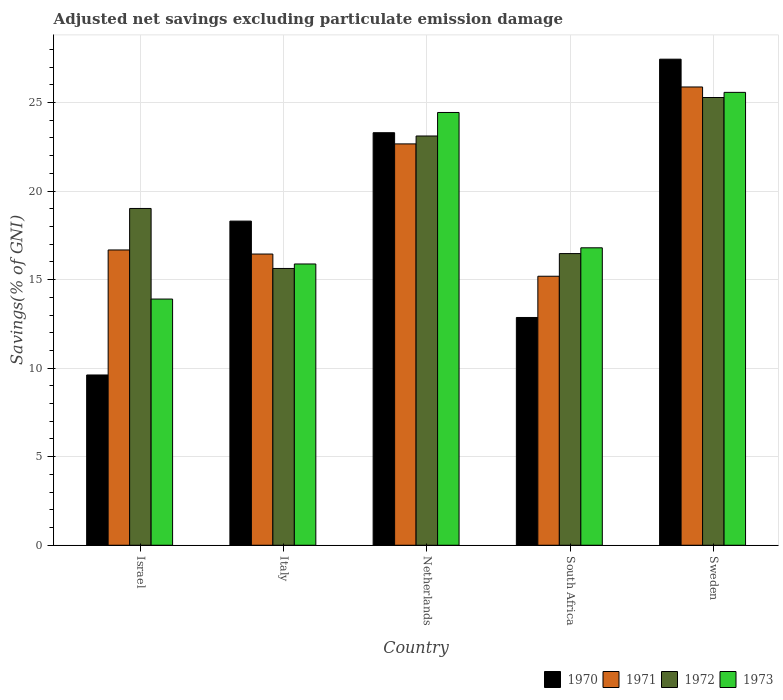How many different coloured bars are there?
Give a very brief answer. 4. How many bars are there on the 4th tick from the left?
Ensure brevity in your answer.  4. What is the adjusted net savings in 1970 in Italy?
Your response must be concise. 18.3. Across all countries, what is the maximum adjusted net savings in 1973?
Keep it short and to the point. 25.57. Across all countries, what is the minimum adjusted net savings in 1971?
Offer a very short reply. 15.19. In which country was the adjusted net savings in 1972 maximum?
Give a very brief answer. Sweden. In which country was the adjusted net savings in 1971 minimum?
Your answer should be compact. South Africa. What is the total adjusted net savings in 1973 in the graph?
Ensure brevity in your answer.  96.59. What is the difference between the adjusted net savings in 1972 in Italy and that in Netherlands?
Ensure brevity in your answer.  -7.48. What is the difference between the adjusted net savings in 1970 in Netherlands and the adjusted net savings in 1971 in Israel?
Give a very brief answer. 6.62. What is the average adjusted net savings in 1970 per country?
Ensure brevity in your answer.  18.3. What is the difference between the adjusted net savings of/in 1973 and adjusted net savings of/in 1970 in Netherlands?
Your response must be concise. 1.14. In how many countries, is the adjusted net savings in 1973 greater than 15 %?
Offer a very short reply. 4. What is the ratio of the adjusted net savings in 1973 in Israel to that in South Africa?
Provide a short and direct response. 0.83. Is the adjusted net savings in 1970 in Israel less than that in Italy?
Your response must be concise. Yes. What is the difference between the highest and the second highest adjusted net savings in 1972?
Make the answer very short. 6.27. What is the difference between the highest and the lowest adjusted net savings in 1973?
Keep it short and to the point. 11.67. In how many countries, is the adjusted net savings in 1972 greater than the average adjusted net savings in 1972 taken over all countries?
Provide a short and direct response. 2. What does the 1st bar from the left in Netherlands represents?
Your answer should be compact. 1970. What does the 1st bar from the right in Italy represents?
Make the answer very short. 1973. Is it the case that in every country, the sum of the adjusted net savings in 1970 and adjusted net savings in 1973 is greater than the adjusted net savings in 1972?
Your response must be concise. Yes. Are all the bars in the graph horizontal?
Offer a very short reply. No. How many countries are there in the graph?
Offer a terse response. 5. Does the graph contain any zero values?
Your response must be concise. No. What is the title of the graph?
Ensure brevity in your answer.  Adjusted net savings excluding particulate emission damage. Does "2007" appear as one of the legend labels in the graph?
Make the answer very short. No. What is the label or title of the X-axis?
Ensure brevity in your answer.  Country. What is the label or title of the Y-axis?
Give a very brief answer. Savings(% of GNI). What is the Savings(% of GNI) of 1970 in Israel?
Provide a short and direct response. 9.61. What is the Savings(% of GNI) of 1971 in Israel?
Provide a succinct answer. 16.67. What is the Savings(% of GNI) of 1972 in Israel?
Your answer should be compact. 19.02. What is the Savings(% of GNI) in 1973 in Israel?
Your answer should be very brief. 13.9. What is the Savings(% of GNI) of 1970 in Italy?
Offer a terse response. 18.3. What is the Savings(% of GNI) of 1971 in Italy?
Ensure brevity in your answer.  16.44. What is the Savings(% of GNI) in 1972 in Italy?
Provide a succinct answer. 15.63. What is the Savings(% of GNI) of 1973 in Italy?
Offer a very short reply. 15.88. What is the Savings(% of GNI) of 1970 in Netherlands?
Provide a succinct answer. 23.3. What is the Savings(% of GNI) in 1971 in Netherlands?
Your answer should be very brief. 22.66. What is the Savings(% of GNI) of 1972 in Netherlands?
Your response must be concise. 23.11. What is the Savings(% of GNI) in 1973 in Netherlands?
Offer a terse response. 24.44. What is the Savings(% of GNI) in 1970 in South Africa?
Offer a very short reply. 12.86. What is the Savings(% of GNI) in 1971 in South Africa?
Provide a succinct answer. 15.19. What is the Savings(% of GNI) in 1972 in South Africa?
Your answer should be compact. 16.47. What is the Savings(% of GNI) in 1973 in South Africa?
Provide a short and direct response. 16.8. What is the Savings(% of GNI) of 1970 in Sweden?
Your answer should be very brief. 27.45. What is the Savings(% of GNI) in 1971 in Sweden?
Give a very brief answer. 25.88. What is the Savings(% of GNI) of 1972 in Sweden?
Keep it short and to the point. 25.28. What is the Savings(% of GNI) of 1973 in Sweden?
Keep it short and to the point. 25.57. Across all countries, what is the maximum Savings(% of GNI) of 1970?
Make the answer very short. 27.45. Across all countries, what is the maximum Savings(% of GNI) of 1971?
Your response must be concise. 25.88. Across all countries, what is the maximum Savings(% of GNI) of 1972?
Give a very brief answer. 25.28. Across all countries, what is the maximum Savings(% of GNI) of 1973?
Your answer should be very brief. 25.57. Across all countries, what is the minimum Savings(% of GNI) in 1970?
Offer a terse response. 9.61. Across all countries, what is the minimum Savings(% of GNI) in 1971?
Make the answer very short. 15.19. Across all countries, what is the minimum Savings(% of GNI) of 1972?
Offer a very short reply. 15.63. Across all countries, what is the minimum Savings(% of GNI) in 1973?
Ensure brevity in your answer.  13.9. What is the total Savings(% of GNI) in 1970 in the graph?
Offer a very short reply. 91.52. What is the total Savings(% of GNI) of 1971 in the graph?
Offer a very short reply. 96.85. What is the total Savings(% of GNI) of 1972 in the graph?
Offer a very short reply. 99.51. What is the total Savings(% of GNI) of 1973 in the graph?
Your answer should be compact. 96.59. What is the difference between the Savings(% of GNI) in 1970 in Israel and that in Italy?
Ensure brevity in your answer.  -8.69. What is the difference between the Savings(% of GNI) of 1971 in Israel and that in Italy?
Your answer should be compact. 0.23. What is the difference between the Savings(% of GNI) of 1972 in Israel and that in Italy?
Offer a very short reply. 3.39. What is the difference between the Savings(% of GNI) of 1973 in Israel and that in Italy?
Give a very brief answer. -1.98. What is the difference between the Savings(% of GNI) of 1970 in Israel and that in Netherlands?
Offer a very short reply. -13.68. What is the difference between the Savings(% of GNI) in 1971 in Israel and that in Netherlands?
Offer a terse response. -5.99. What is the difference between the Savings(% of GNI) of 1972 in Israel and that in Netherlands?
Your answer should be very brief. -4.09. What is the difference between the Savings(% of GNI) of 1973 in Israel and that in Netherlands?
Your response must be concise. -10.54. What is the difference between the Savings(% of GNI) of 1970 in Israel and that in South Africa?
Offer a very short reply. -3.25. What is the difference between the Savings(% of GNI) in 1971 in Israel and that in South Africa?
Make the answer very short. 1.48. What is the difference between the Savings(% of GNI) in 1972 in Israel and that in South Africa?
Your response must be concise. 2.55. What is the difference between the Savings(% of GNI) in 1973 in Israel and that in South Africa?
Your response must be concise. -2.89. What is the difference between the Savings(% of GNI) of 1970 in Israel and that in Sweden?
Give a very brief answer. -17.83. What is the difference between the Savings(% of GNI) of 1971 in Israel and that in Sweden?
Keep it short and to the point. -9.2. What is the difference between the Savings(% of GNI) of 1972 in Israel and that in Sweden?
Offer a very short reply. -6.27. What is the difference between the Savings(% of GNI) of 1973 in Israel and that in Sweden?
Keep it short and to the point. -11.67. What is the difference between the Savings(% of GNI) in 1970 in Italy and that in Netherlands?
Offer a terse response. -4.99. What is the difference between the Savings(% of GNI) of 1971 in Italy and that in Netherlands?
Make the answer very short. -6.22. What is the difference between the Savings(% of GNI) of 1972 in Italy and that in Netherlands?
Make the answer very short. -7.48. What is the difference between the Savings(% of GNI) of 1973 in Italy and that in Netherlands?
Provide a succinct answer. -8.56. What is the difference between the Savings(% of GNI) in 1970 in Italy and that in South Africa?
Make the answer very short. 5.44. What is the difference between the Savings(% of GNI) of 1971 in Italy and that in South Africa?
Your answer should be compact. 1.25. What is the difference between the Savings(% of GNI) of 1972 in Italy and that in South Africa?
Provide a short and direct response. -0.84. What is the difference between the Savings(% of GNI) of 1973 in Italy and that in South Africa?
Your response must be concise. -0.91. What is the difference between the Savings(% of GNI) of 1970 in Italy and that in Sweden?
Provide a succinct answer. -9.14. What is the difference between the Savings(% of GNI) in 1971 in Italy and that in Sweden?
Offer a very short reply. -9.43. What is the difference between the Savings(% of GNI) of 1972 in Italy and that in Sweden?
Your answer should be very brief. -9.65. What is the difference between the Savings(% of GNI) of 1973 in Italy and that in Sweden?
Offer a very short reply. -9.69. What is the difference between the Savings(% of GNI) of 1970 in Netherlands and that in South Africa?
Provide a short and direct response. 10.43. What is the difference between the Savings(% of GNI) of 1971 in Netherlands and that in South Africa?
Your response must be concise. 7.47. What is the difference between the Savings(% of GNI) in 1972 in Netherlands and that in South Africa?
Keep it short and to the point. 6.64. What is the difference between the Savings(% of GNI) of 1973 in Netherlands and that in South Africa?
Provide a short and direct response. 7.64. What is the difference between the Savings(% of GNI) of 1970 in Netherlands and that in Sweden?
Offer a very short reply. -4.15. What is the difference between the Savings(% of GNI) in 1971 in Netherlands and that in Sweden?
Your answer should be very brief. -3.21. What is the difference between the Savings(% of GNI) of 1972 in Netherlands and that in Sweden?
Your response must be concise. -2.17. What is the difference between the Savings(% of GNI) of 1973 in Netherlands and that in Sweden?
Give a very brief answer. -1.14. What is the difference between the Savings(% of GNI) of 1970 in South Africa and that in Sweden?
Your answer should be very brief. -14.59. What is the difference between the Savings(% of GNI) in 1971 in South Africa and that in Sweden?
Your response must be concise. -10.69. What is the difference between the Savings(% of GNI) of 1972 in South Africa and that in Sweden?
Provide a succinct answer. -8.81. What is the difference between the Savings(% of GNI) in 1973 in South Africa and that in Sweden?
Provide a short and direct response. -8.78. What is the difference between the Savings(% of GNI) in 1970 in Israel and the Savings(% of GNI) in 1971 in Italy?
Ensure brevity in your answer.  -6.83. What is the difference between the Savings(% of GNI) in 1970 in Israel and the Savings(% of GNI) in 1972 in Italy?
Your response must be concise. -6.02. What is the difference between the Savings(% of GNI) of 1970 in Israel and the Savings(% of GNI) of 1973 in Italy?
Offer a terse response. -6.27. What is the difference between the Savings(% of GNI) of 1971 in Israel and the Savings(% of GNI) of 1972 in Italy?
Ensure brevity in your answer.  1.04. What is the difference between the Savings(% of GNI) in 1971 in Israel and the Savings(% of GNI) in 1973 in Italy?
Your answer should be compact. 0.79. What is the difference between the Savings(% of GNI) of 1972 in Israel and the Savings(% of GNI) of 1973 in Italy?
Offer a very short reply. 3.14. What is the difference between the Savings(% of GNI) of 1970 in Israel and the Savings(% of GNI) of 1971 in Netherlands?
Your answer should be compact. -13.05. What is the difference between the Savings(% of GNI) of 1970 in Israel and the Savings(% of GNI) of 1972 in Netherlands?
Your response must be concise. -13.49. What is the difference between the Savings(% of GNI) in 1970 in Israel and the Savings(% of GNI) in 1973 in Netherlands?
Your response must be concise. -14.82. What is the difference between the Savings(% of GNI) in 1971 in Israel and the Savings(% of GNI) in 1972 in Netherlands?
Offer a terse response. -6.44. What is the difference between the Savings(% of GNI) of 1971 in Israel and the Savings(% of GNI) of 1973 in Netherlands?
Make the answer very short. -7.76. What is the difference between the Savings(% of GNI) of 1972 in Israel and the Savings(% of GNI) of 1973 in Netherlands?
Your answer should be very brief. -5.42. What is the difference between the Savings(% of GNI) of 1970 in Israel and the Savings(% of GNI) of 1971 in South Africa?
Your response must be concise. -5.58. What is the difference between the Savings(% of GNI) of 1970 in Israel and the Savings(% of GNI) of 1972 in South Africa?
Your answer should be compact. -6.86. What is the difference between the Savings(% of GNI) in 1970 in Israel and the Savings(% of GNI) in 1973 in South Africa?
Provide a short and direct response. -7.18. What is the difference between the Savings(% of GNI) in 1971 in Israel and the Savings(% of GNI) in 1972 in South Africa?
Provide a short and direct response. 0.2. What is the difference between the Savings(% of GNI) in 1971 in Israel and the Savings(% of GNI) in 1973 in South Africa?
Give a very brief answer. -0.12. What is the difference between the Savings(% of GNI) of 1972 in Israel and the Savings(% of GNI) of 1973 in South Africa?
Keep it short and to the point. 2.22. What is the difference between the Savings(% of GNI) in 1970 in Israel and the Savings(% of GNI) in 1971 in Sweden?
Offer a terse response. -16.26. What is the difference between the Savings(% of GNI) in 1970 in Israel and the Savings(% of GNI) in 1972 in Sweden?
Provide a succinct answer. -15.67. What is the difference between the Savings(% of GNI) of 1970 in Israel and the Savings(% of GNI) of 1973 in Sweden?
Offer a very short reply. -15.96. What is the difference between the Savings(% of GNI) of 1971 in Israel and the Savings(% of GNI) of 1972 in Sweden?
Give a very brief answer. -8.61. What is the difference between the Savings(% of GNI) of 1971 in Israel and the Savings(% of GNI) of 1973 in Sweden?
Your response must be concise. -8.9. What is the difference between the Savings(% of GNI) in 1972 in Israel and the Savings(% of GNI) in 1973 in Sweden?
Provide a short and direct response. -6.56. What is the difference between the Savings(% of GNI) of 1970 in Italy and the Savings(% of GNI) of 1971 in Netherlands?
Offer a very short reply. -4.36. What is the difference between the Savings(% of GNI) of 1970 in Italy and the Savings(% of GNI) of 1972 in Netherlands?
Your answer should be very brief. -4.81. What is the difference between the Savings(% of GNI) in 1970 in Italy and the Savings(% of GNI) in 1973 in Netherlands?
Your answer should be compact. -6.13. What is the difference between the Savings(% of GNI) in 1971 in Italy and the Savings(% of GNI) in 1972 in Netherlands?
Offer a very short reply. -6.67. What is the difference between the Savings(% of GNI) of 1971 in Italy and the Savings(% of GNI) of 1973 in Netherlands?
Your response must be concise. -7.99. What is the difference between the Savings(% of GNI) of 1972 in Italy and the Savings(% of GNI) of 1973 in Netherlands?
Keep it short and to the point. -8.81. What is the difference between the Savings(% of GNI) of 1970 in Italy and the Savings(% of GNI) of 1971 in South Africa?
Ensure brevity in your answer.  3.11. What is the difference between the Savings(% of GNI) in 1970 in Italy and the Savings(% of GNI) in 1972 in South Africa?
Keep it short and to the point. 1.83. What is the difference between the Savings(% of GNI) of 1970 in Italy and the Savings(% of GNI) of 1973 in South Africa?
Offer a terse response. 1.51. What is the difference between the Savings(% of GNI) in 1971 in Italy and the Savings(% of GNI) in 1972 in South Africa?
Offer a terse response. -0.03. What is the difference between the Savings(% of GNI) in 1971 in Italy and the Savings(% of GNI) in 1973 in South Africa?
Offer a very short reply. -0.35. What is the difference between the Savings(% of GNI) of 1972 in Italy and the Savings(% of GNI) of 1973 in South Africa?
Make the answer very short. -1.17. What is the difference between the Savings(% of GNI) in 1970 in Italy and the Savings(% of GNI) in 1971 in Sweden?
Your response must be concise. -7.57. What is the difference between the Savings(% of GNI) of 1970 in Italy and the Savings(% of GNI) of 1972 in Sweden?
Provide a succinct answer. -6.98. What is the difference between the Savings(% of GNI) of 1970 in Italy and the Savings(% of GNI) of 1973 in Sweden?
Give a very brief answer. -7.27. What is the difference between the Savings(% of GNI) in 1971 in Italy and the Savings(% of GNI) in 1972 in Sweden?
Give a very brief answer. -8.84. What is the difference between the Savings(% of GNI) in 1971 in Italy and the Savings(% of GNI) in 1973 in Sweden?
Offer a terse response. -9.13. What is the difference between the Savings(% of GNI) in 1972 in Italy and the Savings(% of GNI) in 1973 in Sweden?
Keep it short and to the point. -9.94. What is the difference between the Savings(% of GNI) in 1970 in Netherlands and the Savings(% of GNI) in 1971 in South Africa?
Make the answer very short. 8.11. What is the difference between the Savings(% of GNI) in 1970 in Netherlands and the Savings(% of GNI) in 1972 in South Africa?
Your response must be concise. 6.83. What is the difference between the Savings(% of GNI) of 1970 in Netherlands and the Savings(% of GNI) of 1973 in South Africa?
Your answer should be compact. 6.5. What is the difference between the Savings(% of GNI) of 1971 in Netherlands and the Savings(% of GNI) of 1972 in South Africa?
Keep it short and to the point. 6.19. What is the difference between the Savings(% of GNI) in 1971 in Netherlands and the Savings(% of GNI) in 1973 in South Africa?
Offer a very short reply. 5.87. What is the difference between the Savings(% of GNI) of 1972 in Netherlands and the Savings(% of GNI) of 1973 in South Africa?
Your answer should be very brief. 6.31. What is the difference between the Savings(% of GNI) of 1970 in Netherlands and the Savings(% of GNI) of 1971 in Sweden?
Make the answer very short. -2.58. What is the difference between the Savings(% of GNI) in 1970 in Netherlands and the Savings(% of GNI) in 1972 in Sweden?
Ensure brevity in your answer.  -1.99. What is the difference between the Savings(% of GNI) of 1970 in Netherlands and the Savings(% of GNI) of 1973 in Sweden?
Your answer should be compact. -2.28. What is the difference between the Savings(% of GNI) of 1971 in Netherlands and the Savings(% of GNI) of 1972 in Sweden?
Offer a terse response. -2.62. What is the difference between the Savings(% of GNI) in 1971 in Netherlands and the Savings(% of GNI) in 1973 in Sweden?
Offer a terse response. -2.91. What is the difference between the Savings(% of GNI) of 1972 in Netherlands and the Savings(% of GNI) of 1973 in Sweden?
Keep it short and to the point. -2.46. What is the difference between the Savings(% of GNI) in 1970 in South Africa and the Savings(% of GNI) in 1971 in Sweden?
Make the answer very short. -13.02. What is the difference between the Savings(% of GNI) in 1970 in South Africa and the Savings(% of GNI) in 1972 in Sweden?
Keep it short and to the point. -12.42. What is the difference between the Savings(% of GNI) of 1970 in South Africa and the Savings(% of GNI) of 1973 in Sweden?
Give a very brief answer. -12.71. What is the difference between the Savings(% of GNI) in 1971 in South Africa and the Savings(% of GNI) in 1972 in Sweden?
Make the answer very short. -10.09. What is the difference between the Savings(% of GNI) of 1971 in South Africa and the Savings(% of GNI) of 1973 in Sweden?
Ensure brevity in your answer.  -10.38. What is the difference between the Savings(% of GNI) of 1972 in South Africa and the Savings(% of GNI) of 1973 in Sweden?
Offer a very short reply. -9.1. What is the average Savings(% of GNI) of 1970 per country?
Provide a short and direct response. 18.3. What is the average Savings(% of GNI) in 1971 per country?
Keep it short and to the point. 19.37. What is the average Savings(% of GNI) of 1972 per country?
Your answer should be compact. 19.9. What is the average Savings(% of GNI) of 1973 per country?
Provide a succinct answer. 19.32. What is the difference between the Savings(% of GNI) in 1970 and Savings(% of GNI) in 1971 in Israel?
Your answer should be very brief. -7.06. What is the difference between the Savings(% of GNI) in 1970 and Savings(% of GNI) in 1972 in Israel?
Your response must be concise. -9.4. What is the difference between the Savings(% of GNI) in 1970 and Savings(% of GNI) in 1973 in Israel?
Your response must be concise. -4.29. What is the difference between the Savings(% of GNI) in 1971 and Savings(% of GNI) in 1972 in Israel?
Make the answer very short. -2.34. What is the difference between the Savings(% of GNI) of 1971 and Savings(% of GNI) of 1973 in Israel?
Offer a terse response. 2.77. What is the difference between the Savings(% of GNI) in 1972 and Savings(% of GNI) in 1973 in Israel?
Make the answer very short. 5.12. What is the difference between the Savings(% of GNI) in 1970 and Savings(% of GNI) in 1971 in Italy?
Your answer should be compact. 1.86. What is the difference between the Savings(% of GNI) in 1970 and Savings(% of GNI) in 1972 in Italy?
Your answer should be compact. 2.67. What is the difference between the Savings(% of GNI) in 1970 and Savings(% of GNI) in 1973 in Italy?
Offer a terse response. 2.42. What is the difference between the Savings(% of GNI) in 1971 and Savings(% of GNI) in 1972 in Italy?
Offer a very short reply. 0.81. What is the difference between the Savings(% of GNI) of 1971 and Savings(% of GNI) of 1973 in Italy?
Ensure brevity in your answer.  0.56. What is the difference between the Savings(% of GNI) of 1972 and Savings(% of GNI) of 1973 in Italy?
Provide a short and direct response. -0.25. What is the difference between the Savings(% of GNI) in 1970 and Savings(% of GNI) in 1971 in Netherlands?
Give a very brief answer. 0.63. What is the difference between the Savings(% of GNI) of 1970 and Savings(% of GNI) of 1972 in Netherlands?
Keep it short and to the point. 0.19. What is the difference between the Savings(% of GNI) in 1970 and Savings(% of GNI) in 1973 in Netherlands?
Offer a terse response. -1.14. What is the difference between the Savings(% of GNI) of 1971 and Savings(% of GNI) of 1972 in Netherlands?
Provide a succinct answer. -0.45. What is the difference between the Savings(% of GNI) of 1971 and Savings(% of GNI) of 1973 in Netherlands?
Provide a short and direct response. -1.77. What is the difference between the Savings(% of GNI) in 1972 and Savings(% of GNI) in 1973 in Netherlands?
Make the answer very short. -1.33. What is the difference between the Savings(% of GNI) of 1970 and Savings(% of GNI) of 1971 in South Africa?
Provide a succinct answer. -2.33. What is the difference between the Savings(% of GNI) of 1970 and Savings(% of GNI) of 1972 in South Africa?
Make the answer very short. -3.61. What is the difference between the Savings(% of GNI) in 1970 and Savings(% of GNI) in 1973 in South Africa?
Give a very brief answer. -3.93. What is the difference between the Savings(% of GNI) in 1971 and Savings(% of GNI) in 1972 in South Africa?
Your answer should be very brief. -1.28. What is the difference between the Savings(% of GNI) of 1971 and Savings(% of GNI) of 1973 in South Africa?
Offer a terse response. -1.61. What is the difference between the Savings(% of GNI) of 1972 and Savings(% of GNI) of 1973 in South Africa?
Your answer should be very brief. -0.33. What is the difference between the Savings(% of GNI) in 1970 and Savings(% of GNI) in 1971 in Sweden?
Offer a very short reply. 1.57. What is the difference between the Savings(% of GNI) of 1970 and Savings(% of GNI) of 1972 in Sweden?
Provide a succinct answer. 2.16. What is the difference between the Savings(% of GNI) in 1970 and Savings(% of GNI) in 1973 in Sweden?
Offer a terse response. 1.87. What is the difference between the Savings(% of GNI) of 1971 and Savings(% of GNI) of 1972 in Sweden?
Provide a succinct answer. 0.59. What is the difference between the Savings(% of GNI) of 1971 and Savings(% of GNI) of 1973 in Sweden?
Provide a succinct answer. 0.3. What is the difference between the Savings(% of GNI) of 1972 and Savings(% of GNI) of 1973 in Sweden?
Your response must be concise. -0.29. What is the ratio of the Savings(% of GNI) in 1970 in Israel to that in Italy?
Your response must be concise. 0.53. What is the ratio of the Savings(% of GNI) of 1972 in Israel to that in Italy?
Provide a succinct answer. 1.22. What is the ratio of the Savings(% of GNI) in 1973 in Israel to that in Italy?
Give a very brief answer. 0.88. What is the ratio of the Savings(% of GNI) in 1970 in Israel to that in Netherlands?
Your answer should be very brief. 0.41. What is the ratio of the Savings(% of GNI) in 1971 in Israel to that in Netherlands?
Your answer should be compact. 0.74. What is the ratio of the Savings(% of GNI) of 1972 in Israel to that in Netherlands?
Keep it short and to the point. 0.82. What is the ratio of the Savings(% of GNI) of 1973 in Israel to that in Netherlands?
Provide a short and direct response. 0.57. What is the ratio of the Savings(% of GNI) of 1970 in Israel to that in South Africa?
Your answer should be very brief. 0.75. What is the ratio of the Savings(% of GNI) of 1971 in Israel to that in South Africa?
Your answer should be compact. 1.1. What is the ratio of the Savings(% of GNI) in 1972 in Israel to that in South Africa?
Offer a terse response. 1.15. What is the ratio of the Savings(% of GNI) in 1973 in Israel to that in South Africa?
Your answer should be compact. 0.83. What is the ratio of the Savings(% of GNI) in 1970 in Israel to that in Sweden?
Offer a very short reply. 0.35. What is the ratio of the Savings(% of GNI) of 1971 in Israel to that in Sweden?
Make the answer very short. 0.64. What is the ratio of the Savings(% of GNI) in 1972 in Israel to that in Sweden?
Ensure brevity in your answer.  0.75. What is the ratio of the Savings(% of GNI) of 1973 in Israel to that in Sweden?
Provide a succinct answer. 0.54. What is the ratio of the Savings(% of GNI) of 1970 in Italy to that in Netherlands?
Keep it short and to the point. 0.79. What is the ratio of the Savings(% of GNI) of 1971 in Italy to that in Netherlands?
Offer a very short reply. 0.73. What is the ratio of the Savings(% of GNI) in 1972 in Italy to that in Netherlands?
Your answer should be compact. 0.68. What is the ratio of the Savings(% of GNI) in 1973 in Italy to that in Netherlands?
Make the answer very short. 0.65. What is the ratio of the Savings(% of GNI) in 1970 in Italy to that in South Africa?
Offer a very short reply. 1.42. What is the ratio of the Savings(% of GNI) in 1971 in Italy to that in South Africa?
Your answer should be compact. 1.08. What is the ratio of the Savings(% of GNI) in 1972 in Italy to that in South Africa?
Your answer should be compact. 0.95. What is the ratio of the Savings(% of GNI) of 1973 in Italy to that in South Africa?
Your answer should be compact. 0.95. What is the ratio of the Savings(% of GNI) of 1970 in Italy to that in Sweden?
Ensure brevity in your answer.  0.67. What is the ratio of the Savings(% of GNI) in 1971 in Italy to that in Sweden?
Ensure brevity in your answer.  0.64. What is the ratio of the Savings(% of GNI) in 1972 in Italy to that in Sweden?
Provide a succinct answer. 0.62. What is the ratio of the Savings(% of GNI) of 1973 in Italy to that in Sweden?
Make the answer very short. 0.62. What is the ratio of the Savings(% of GNI) in 1970 in Netherlands to that in South Africa?
Make the answer very short. 1.81. What is the ratio of the Savings(% of GNI) in 1971 in Netherlands to that in South Africa?
Provide a succinct answer. 1.49. What is the ratio of the Savings(% of GNI) of 1972 in Netherlands to that in South Africa?
Keep it short and to the point. 1.4. What is the ratio of the Savings(% of GNI) of 1973 in Netherlands to that in South Africa?
Give a very brief answer. 1.46. What is the ratio of the Savings(% of GNI) in 1970 in Netherlands to that in Sweden?
Your answer should be compact. 0.85. What is the ratio of the Savings(% of GNI) of 1971 in Netherlands to that in Sweden?
Provide a short and direct response. 0.88. What is the ratio of the Savings(% of GNI) of 1972 in Netherlands to that in Sweden?
Provide a succinct answer. 0.91. What is the ratio of the Savings(% of GNI) in 1973 in Netherlands to that in Sweden?
Offer a terse response. 0.96. What is the ratio of the Savings(% of GNI) in 1970 in South Africa to that in Sweden?
Your response must be concise. 0.47. What is the ratio of the Savings(% of GNI) in 1971 in South Africa to that in Sweden?
Your answer should be very brief. 0.59. What is the ratio of the Savings(% of GNI) of 1972 in South Africa to that in Sweden?
Give a very brief answer. 0.65. What is the ratio of the Savings(% of GNI) of 1973 in South Africa to that in Sweden?
Keep it short and to the point. 0.66. What is the difference between the highest and the second highest Savings(% of GNI) of 1970?
Your answer should be very brief. 4.15. What is the difference between the highest and the second highest Savings(% of GNI) in 1971?
Offer a terse response. 3.21. What is the difference between the highest and the second highest Savings(% of GNI) of 1972?
Provide a succinct answer. 2.17. What is the difference between the highest and the second highest Savings(% of GNI) of 1973?
Offer a terse response. 1.14. What is the difference between the highest and the lowest Savings(% of GNI) in 1970?
Keep it short and to the point. 17.83. What is the difference between the highest and the lowest Savings(% of GNI) in 1971?
Ensure brevity in your answer.  10.69. What is the difference between the highest and the lowest Savings(% of GNI) in 1972?
Your answer should be very brief. 9.65. What is the difference between the highest and the lowest Savings(% of GNI) of 1973?
Provide a short and direct response. 11.67. 